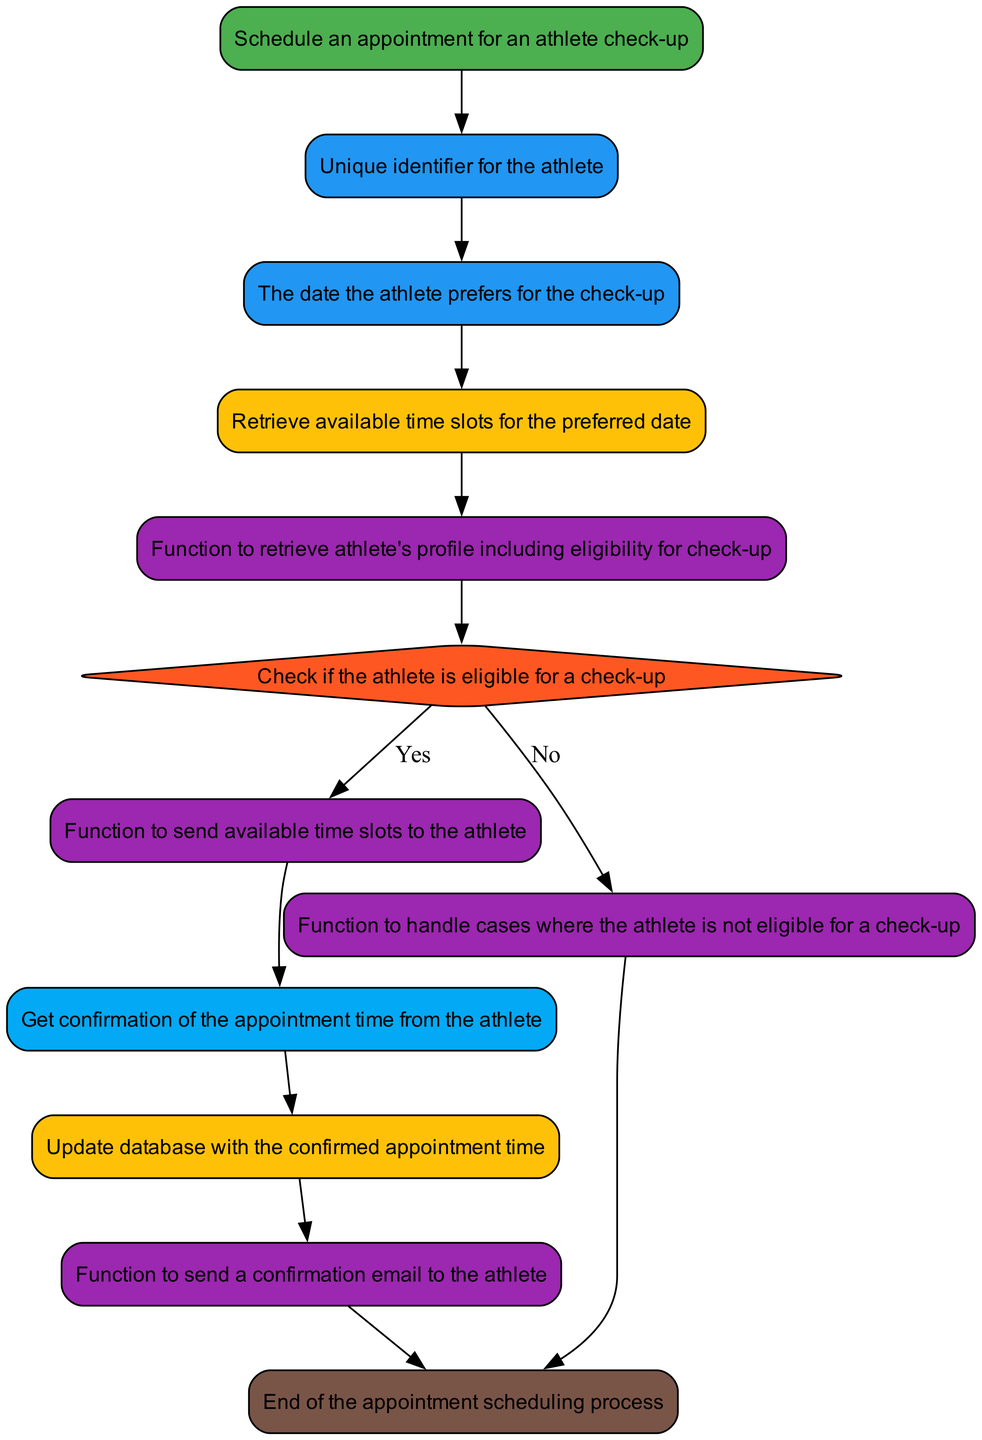What is the main function in this diagram? The main function is indicated as the starting node in the diagram, which is named "function_schedule_appointment." This node sets the context for the entire flow of scheduling an appointment for athlete check-ups.
Answer: function_schedule_appointment How many parameter nodes are present? The diagram includes two parameter nodes: "athlete_id" and "preferred_date." These parameters are essential inputs needed to schedule an appointment.
Answer: 2 What happens if the athlete is not eligible for a check-up? According to the flow, if the athlete is not eligible, it leads to the "handle_non_eligible_athlete" function call, which means specific procedures will follow for non-eligible cases.
Answer: handle_non_eligible_athlete What is the last function that is called before the process ends? The last function called before reaching the end of the flow is "send_confirmation_email," which sends out a confirmation to the athlete regarding their appointment.
Answer: send_confirmation_email Describe the path from "preferred_date" to "confirm_eligibility." The path starts at "preferred_date," which connects to "available_slots," and from there, it leads to "check_athlete_profile." Finally, this node connects to "confirm_eligibility," which checks the athlete's eligibility based on the information retrieved.
Answer: preferred_date → available_slots → check_athlete_profile → confirm_eligibility What does the function "send_availability_notification" do? This function sends the available time slots for the preferred date to the athlete, facilitating their choice of appointment times. It bridges the decision of eligibility to the final confirmation of appointment.
Answer: send_availability_notification 